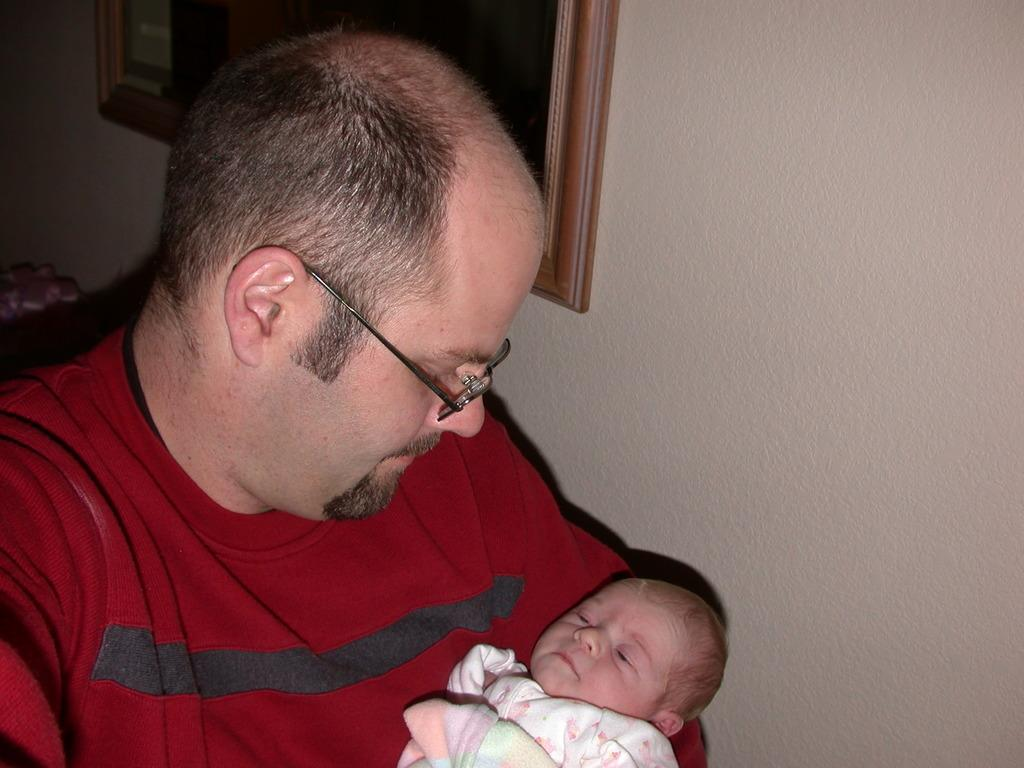What is the primary subject of the image? There is a human sitting in the image. What is the human doing in the image? The human is holding a baby. What can be seen on the wall in the image? There is a photo frame on the wall in the image. How many fish are swimming in the baby's hair in the image? There are no fish present in the image, so it is not possible to determine how many might be swimming in the baby's hair. 